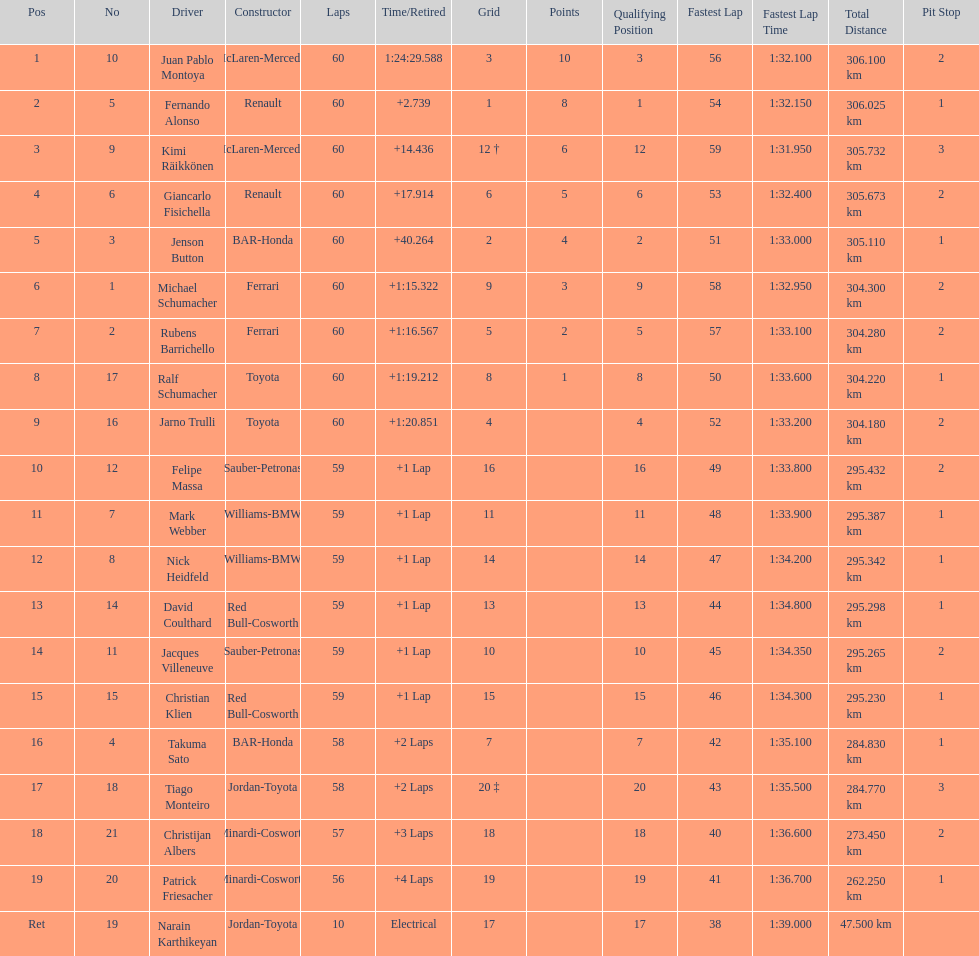After 8th position, how many points does a driver receive? 0. 